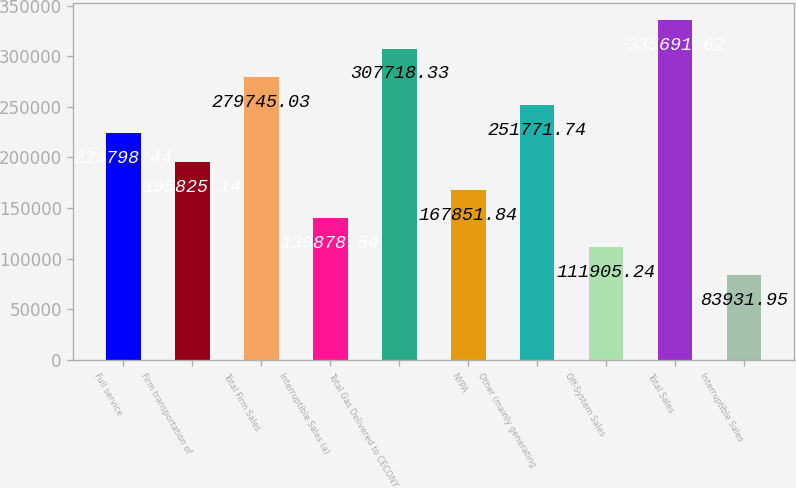<chart> <loc_0><loc_0><loc_500><loc_500><bar_chart><fcel>Full service<fcel>Firm transportation of<fcel>Total Firm Sales<fcel>Interruptible Sales (a)<fcel>Total Gas Delivered to CECONY<fcel>NYPA<fcel>Other (mainly generating<fcel>Off-System Sales<fcel>Total Sales<fcel>Interruptible Sales<nl><fcel>223798<fcel>195825<fcel>279745<fcel>139879<fcel>307718<fcel>167852<fcel>251772<fcel>111905<fcel>335692<fcel>83931.9<nl></chart> 